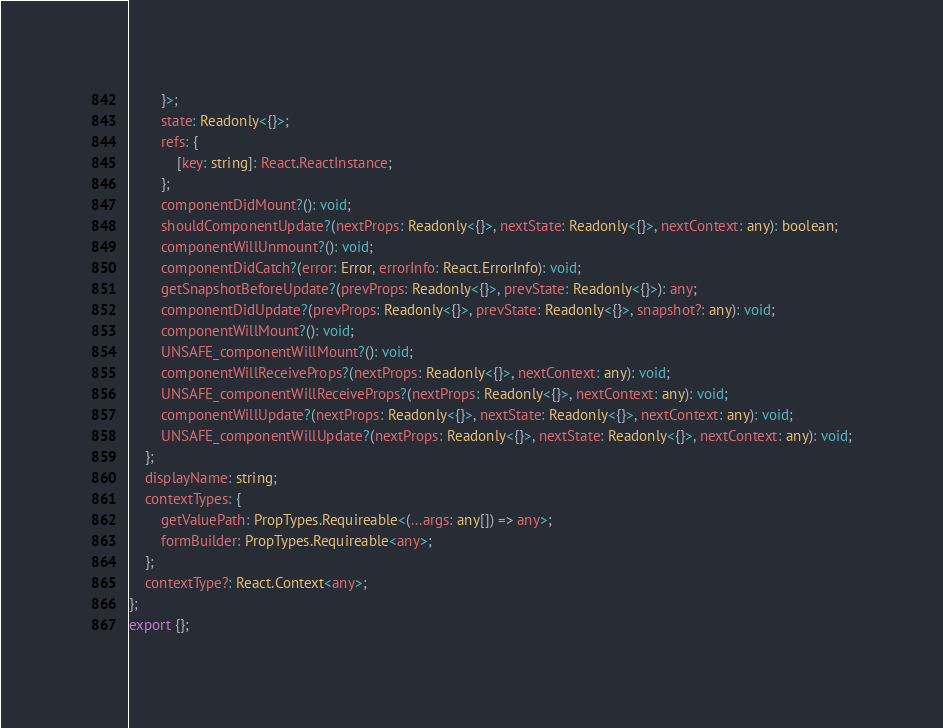<code> <loc_0><loc_0><loc_500><loc_500><_TypeScript_>        }>;
        state: Readonly<{}>;
        refs: {
            [key: string]: React.ReactInstance;
        };
        componentDidMount?(): void;
        shouldComponentUpdate?(nextProps: Readonly<{}>, nextState: Readonly<{}>, nextContext: any): boolean;
        componentWillUnmount?(): void;
        componentDidCatch?(error: Error, errorInfo: React.ErrorInfo): void;
        getSnapshotBeforeUpdate?(prevProps: Readonly<{}>, prevState: Readonly<{}>): any;
        componentDidUpdate?(prevProps: Readonly<{}>, prevState: Readonly<{}>, snapshot?: any): void;
        componentWillMount?(): void;
        UNSAFE_componentWillMount?(): void;
        componentWillReceiveProps?(nextProps: Readonly<{}>, nextContext: any): void;
        UNSAFE_componentWillReceiveProps?(nextProps: Readonly<{}>, nextContext: any): void;
        componentWillUpdate?(nextProps: Readonly<{}>, nextState: Readonly<{}>, nextContext: any): void;
        UNSAFE_componentWillUpdate?(nextProps: Readonly<{}>, nextState: Readonly<{}>, nextContext: any): void;
    };
    displayName: string;
    contextTypes: {
        getValuePath: PropTypes.Requireable<(...args: any[]) => any>;
        formBuilder: PropTypes.Requireable<any>;
    };
    contextType?: React.Context<any>;
};
export {};
</code> 